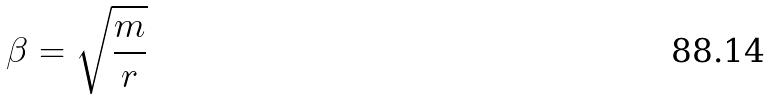<formula> <loc_0><loc_0><loc_500><loc_500>\beta = \sqrt { \frac { m } { r } }</formula> 